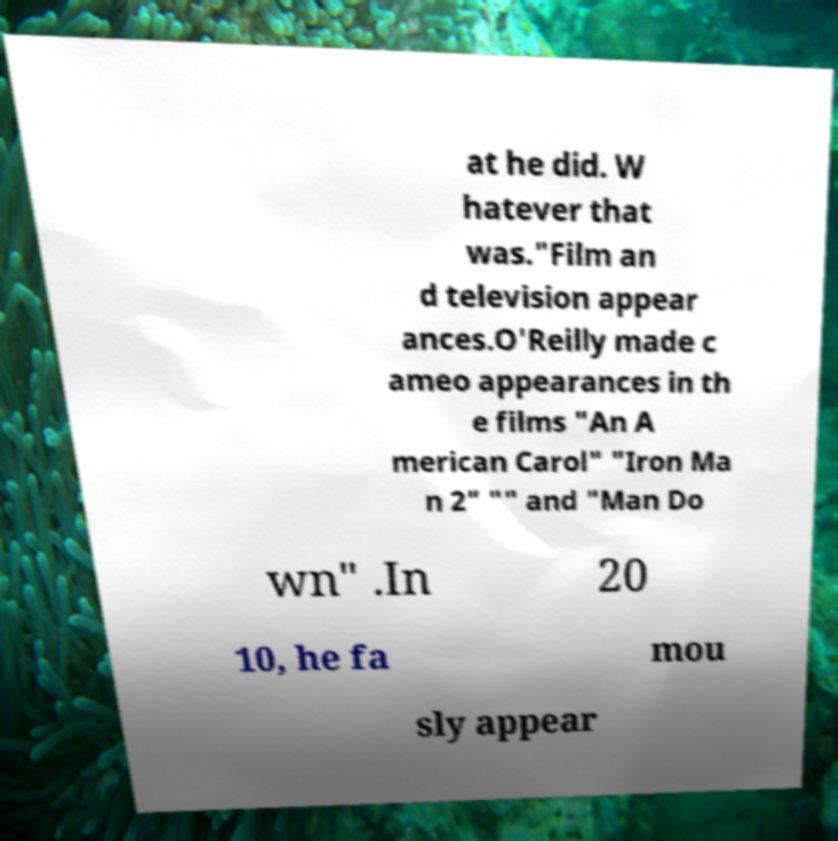Could you extract and type out the text from this image? at he did. W hatever that was."Film an d television appear ances.O'Reilly made c ameo appearances in th e films "An A merican Carol" "Iron Ma n 2" "" and "Man Do wn" .In 20 10, he fa mou sly appear 